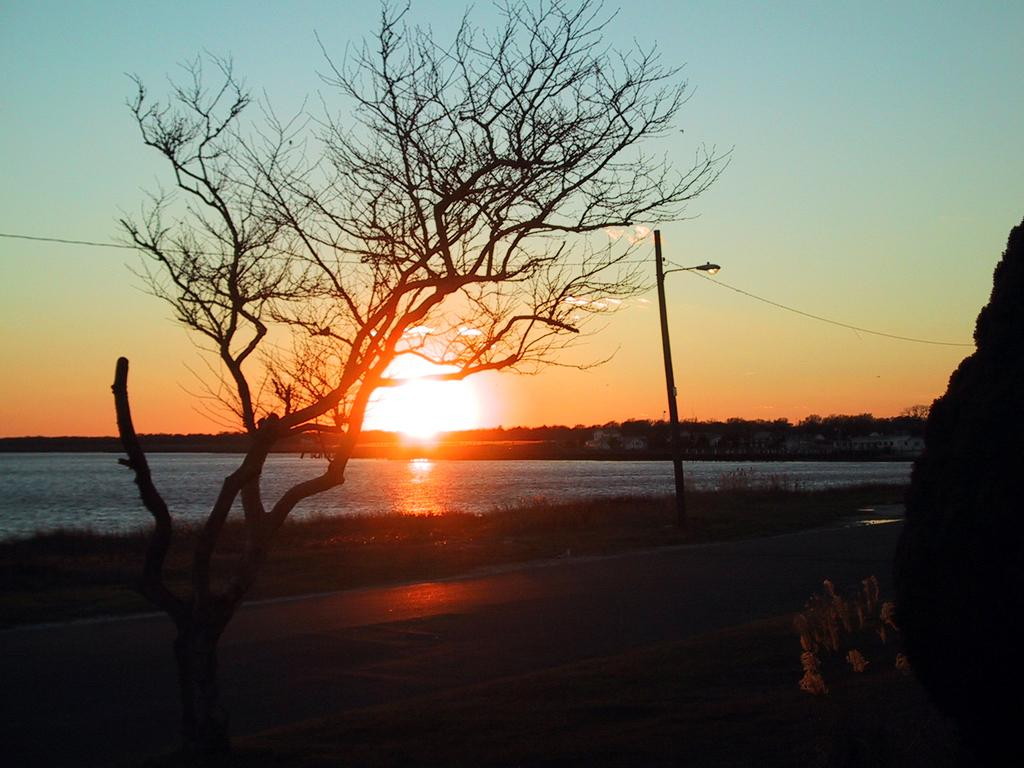What is located in the foreground of the image? There is a road in the foreground of the image. What can be seen in the background of the image? There are trees, grassland, water, houses, a pole, wires, and the sky visible in the background of the image. How many dogs are playing with the idea in the image? There are no dogs or ideas present in the image. Are there any horses visible in the image? There are no horses visible in the image. 